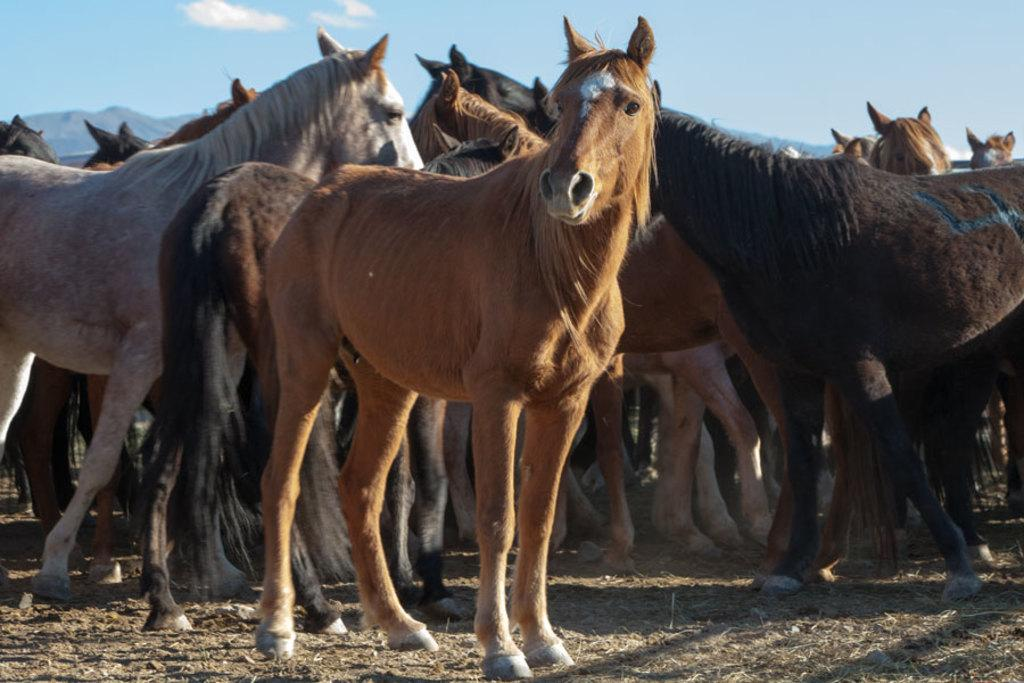What animals are present in the image? There are horses in the image. Where are the horses located? The horses are on the ground. What direction are the horses facing in the image? The provided facts do not mention the direction the horses are facing, so it cannot be determined from the image. 